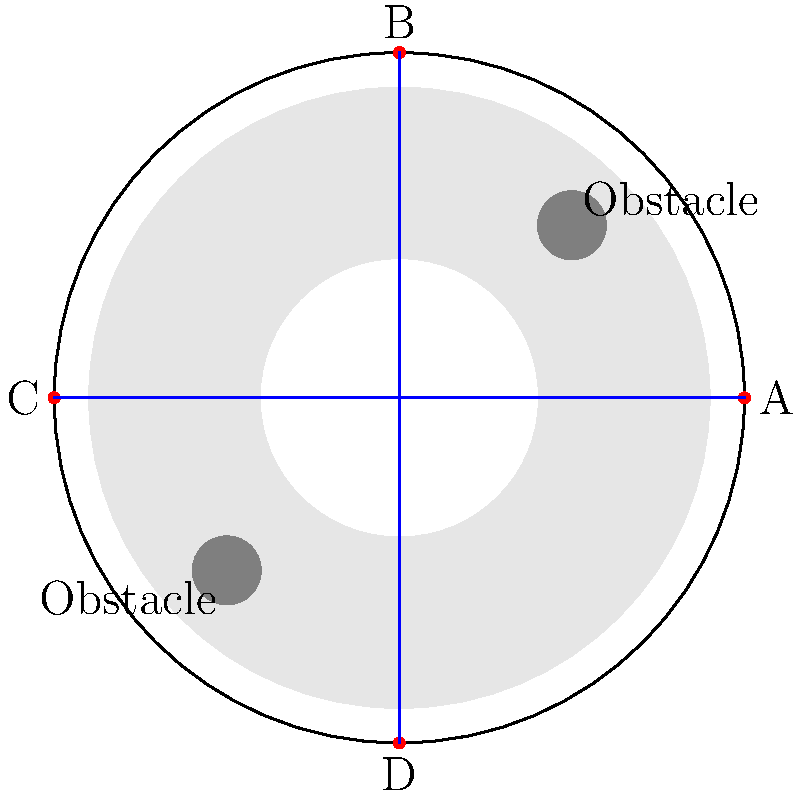In the stadium layout shown, four emergency exits (A, B, C, and D) are marked in red. Given the presence of obstacles and the circular seating arrangement, which exit path from the center of the stadium is likely to be the most efficient for evacuation? To determine the most efficient emergency exit path, we need to consider several factors:

1. Distance: All exits are equidistant from the center, so this is not a determining factor.

2. Obstacles: There are two obstacles in the stadium, located at (5,5) and (-5,-5).

3. Crowd flow: The circular seating arrangement means that people will naturally move radially outward.

4. Path obstruction:
   - Path to Exit A: Clear, no obstacles
   - Path to Exit B: Clear, no obstacles
   - Path to Exit C: Partially obstructed by the obstacle at (-5,-5)
   - Path to Exit D: Partially obstructed by the obstacle at (5,5)

5. Evacuation efficiency: 
   - Exits A and B have clear paths, allowing for smoother crowd movement.
   - Exits C and D have obstacles that could create bottlenecks and slow down evacuation.

6. Multiple exit strategy: In a real evacuation, multiple exits would be used. However, the question asks for the most efficient single path.

Based on these considerations, the paths to either Exit A or Exit B would be the most efficient. However, Exit A (to the right) is slightly favored because:

- It aligns with the conventional "keep right" flow of foot traffic in many cultures.
- It provides a clear line of sight from the center to the exit, which can help with wayfinding during an emergency.

Therefore, the path to Exit A is likely to be the most efficient for evacuation from the center of the stadium.
Answer: Exit A 